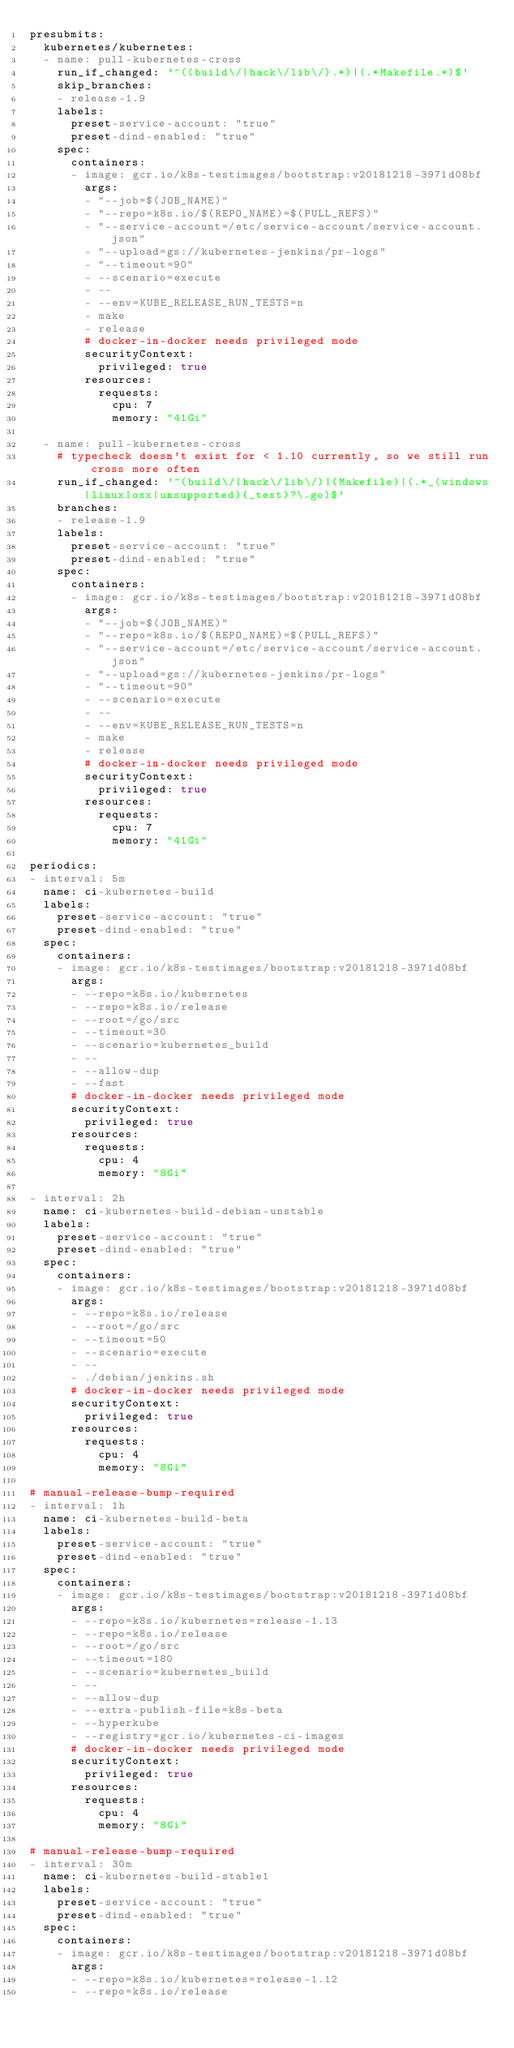<code> <loc_0><loc_0><loc_500><loc_500><_YAML_>presubmits:
  kubernetes/kubernetes:
  - name: pull-kubernetes-cross
    run_if_changed: '^((build\/|hack\/lib\/).*)|(.*Makefile.*)$'
    skip_branches:
    - release-1.9
    labels:
      preset-service-account: "true"
      preset-dind-enabled: "true"
    spec:
      containers:
      - image: gcr.io/k8s-testimages/bootstrap:v20181218-3971d08bf
        args:
        - "--job=$(JOB_NAME)"
        - "--repo=k8s.io/$(REPO_NAME)=$(PULL_REFS)"
        - "--service-account=/etc/service-account/service-account.json"
        - "--upload=gs://kubernetes-jenkins/pr-logs"
        - "--timeout=90"
        - --scenario=execute
        - --
        - --env=KUBE_RELEASE_RUN_TESTS=n
        - make
        - release
        # docker-in-docker needs privileged mode
        securityContext:
          privileged: true
        resources:
          requests:
            cpu: 7
            memory: "41Gi"

  - name: pull-kubernetes-cross
    # typecheck doesn't exist for < 1.10 currently, so we still run cross more often
    run_if_changed: '^(build\/|hack\/lib\/)|(Makefile)|(.*_(windows|linux|osx|unsupported)(_test)?\.go)$'
    branches:
    - release-1.9
    labels:
      preset-service-account: "true"
      preset-dind-enabled: "true"
    spec:
      containers:
      - image: gcr.io/k8s-testimages/bootstrap:v20181218-3971d08bf
        args:
        - "--job=$(JOB_NAME)"
        - "--repo=k8s.io/$(REPO_NAME)=$(PULL_REFS)"
        - "--service-account=/etc/service-account/service-account.json"
        - "--upload=gs://kubernetes-jenkins/pr-logs"
        - "--timeout=90"
        - --scenario=execute
        - --
        - --env=KUBE_RELEASE_RUN_TESTS=n
        - make
        - release
        # docker-in-docker needs privileged mode
        securityContext:
          privileged: true
        resources:
          requests:
            cpu: 7
            memory: "41Gi"

periodics:
- interval: 5m
  name: ci-kubernetes-build
  labels:
    preset-service-account: "true"
    preset-dind-enabled: "true"
  spec:
    containers:
    - image: gcr.io/k8s-testimages/bootstrap:v20181218-3971d08bf
      args:
      - --repo=k8s.io/kubernetes
      - --repo=k8s.io/release
      - --root=/go/src
      - --timeout=30
      - --scenario=kubernetes_build
      - --
      - --allow-dup
      - --fast
      # docker-in-docker needs privileged mode
      securityContext:
        privileged: true
      resources:
        requests:
          cpu: 4
          memory: "8Gi"

- interval: 2h
  name: ci-kubernetes-build-debian-unstable
  labels:
    preset-service-account: "true"
    preset-dind-enabled: "true"
  spec:
    containers:
    - image: gcr.io/k8s-testimages/bootstrap:v20181218-3971d08bf
      args:
      - --repo=k8s.io/release
      - --root=/go/src
      - --timeout=50
      - --scenario=execute
      - --
      - ./debian/jenkins.sh
      # docker-in-docker needs privileged mode
      securityContext:
        privileged: true
      resources:
        requests:
          cpu: 4
          memory: "8Gi"

# manual-release-bump-required
- interval: 1h
  name: ci-kubernetes-build-beta
  labels:
    preset-service-account: "true"
    preset-dind-enabled: "true"
  spec:
    containers:
    - image: gcr.io/k8s-testimages/bootstrap:v20181218-3971d08bf
      args:
      - --repo=k8s.io/kubernetes=release-1.13
      - --repo=k8s.io/release
      - --root=/go/src
      - --timeout=180
      - --scenario=kubernetes_build
      - --
      - --allow-dup
      - --extra-publish-file=k8s-beta
      - --hyperkube
      - --registry=gcr.io/kubernetes-ci-images
      # docker-in-docker needs privileged mode
      securityContext:
        privileged: true
      resources:
        requests:
          cpu: 4
          memory: "8Gi"

# manual-release-bump-required
- interval: 30m
  name: ci-kubernetes-build-stable1
  labels:
    preset-service-account: "true"
    preset-dind-enabled: "true"
  spec:
    containers:
    - image: gcr.io/k8s-testimages/bootstrap:v20181218-3971d08bf
      args:
      - --repo=k8s.io/kubernetes=release-1.12
      - --repo=k8s.io/release</code> 